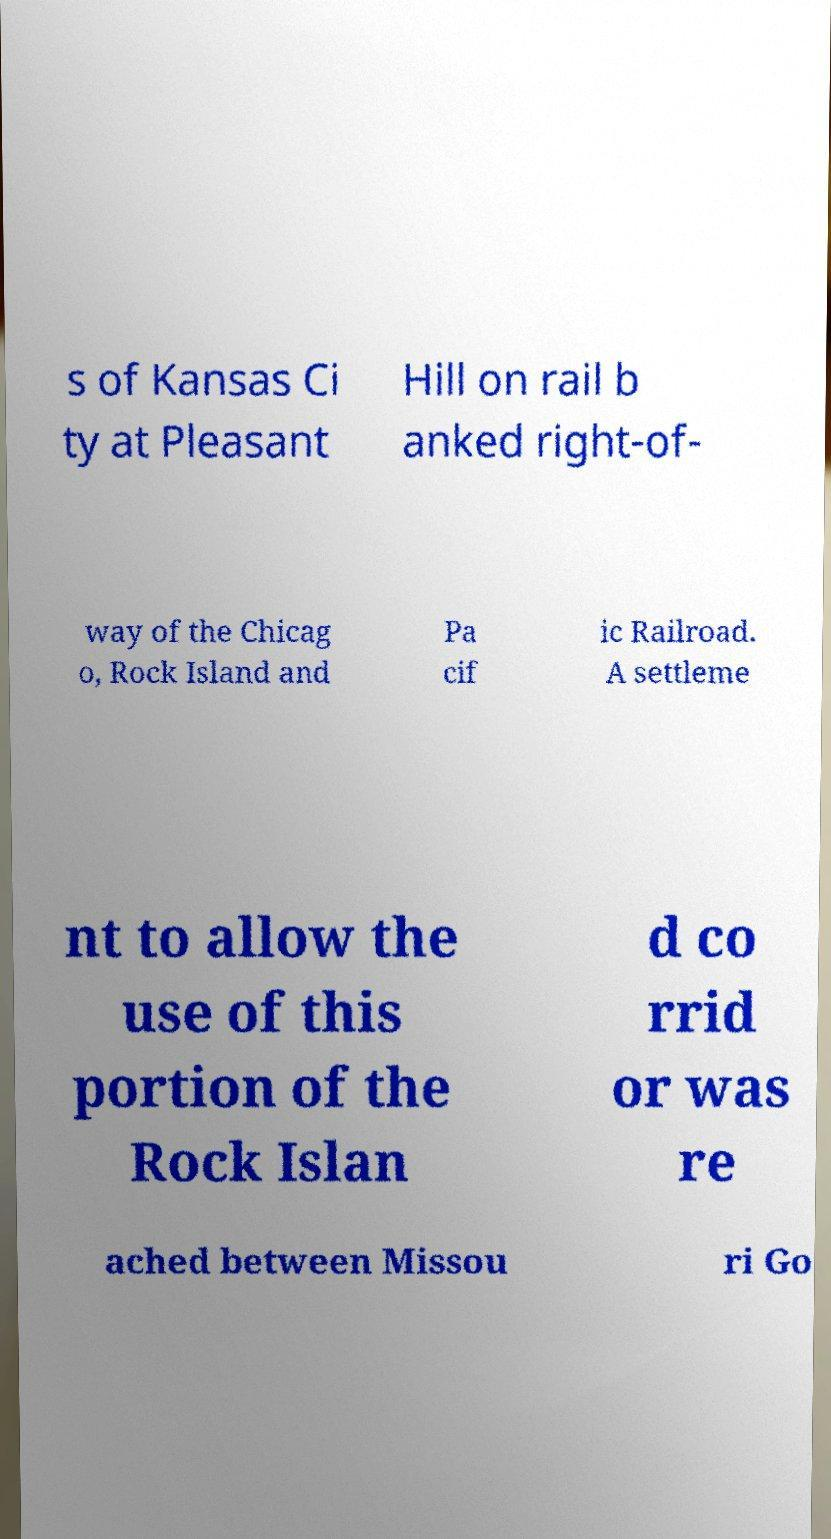For documentation purposes, I need the text within this image transcribed. Could you provide that? s of Kansas Ci ty at Pleasant Hill on rail b anked right-of- way of the Chicag o, Rock Island and Pa cif ic Railroad. A settleme nt to allow the use of this portion of the Rock Islan d co rrid or was re ached between Missou ri Go 